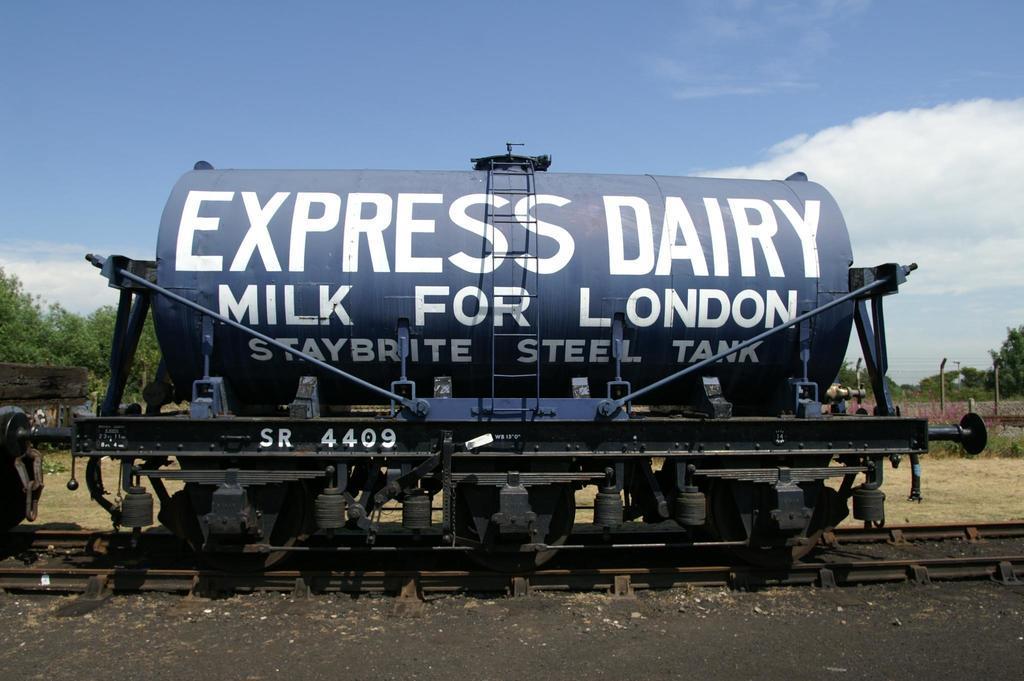How would you summarize this image in a sentence or two? In this image I can see the tank on the railway track. Back I can see few trees, fencing and the wall. The sky is in blue and white color. 